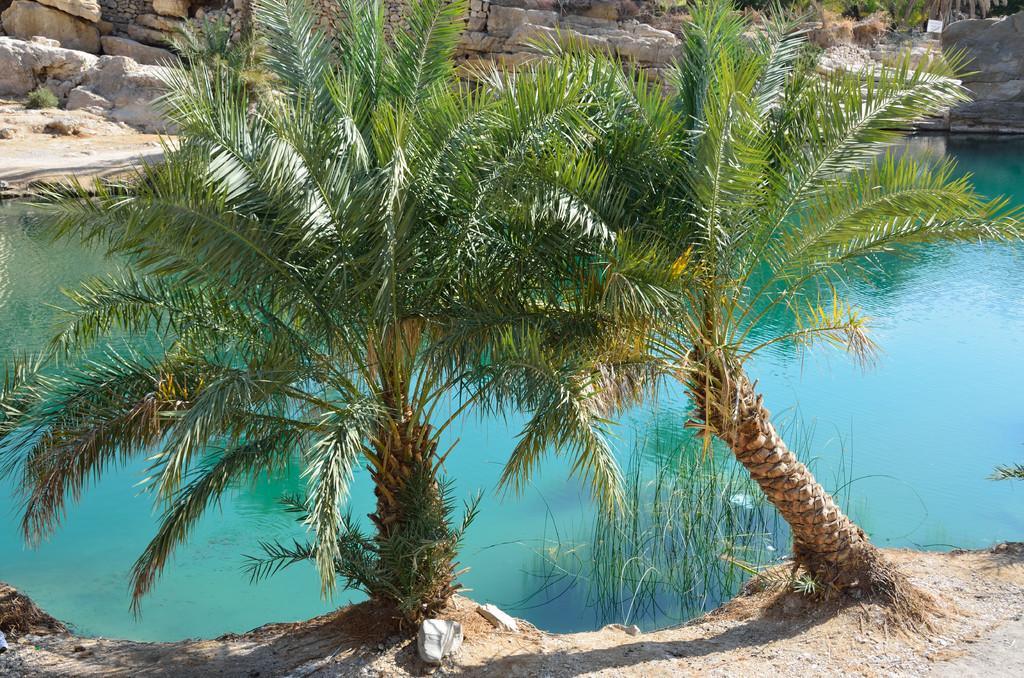Please provide a concise description of this image. In the foreground of this image, there are two trees. Behind it, there is water and in the background, there are stones. 